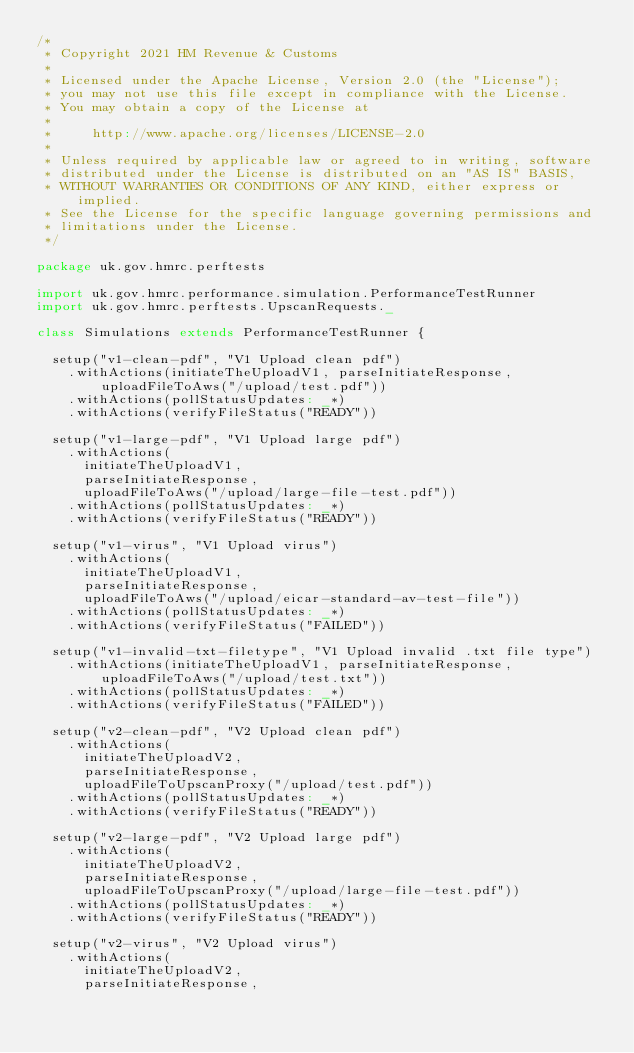<code> <loc_0><loc_0><loc_500><loc_500><_Scala_>/*
 * Copyright 2021 HM Revenue & Customs
 *
 * Licensed under the Apache License, Version 2.0 (the "License");
 * you may not use this file except in compliance with the License.
 * You may obtain a copy of the License at
 *
 *     http://www.apache.org/licenses/LICENSE-2.0
 *
 * Unless required by applicable law or agreed to in writing, software
 * distributed under the License is distributed on an "AS IS" BASIS,
 * WITHOUT WARRANTIES OR CONDITIONS OF ANY KIND, either express or implied.
 * See the License for the specific language governing permissions and
 * limitations under the License.
 */

package uk.gov.hmrc.perftests

import uk.gov.hmrc.performance.simulation.PerformanceTestRunner
import uk.gov.hmrc.perftests.UpscanRequests._

class Simulations extends PerformanceTestRunner {

  setup("v1-clean-pdf", "V1 Upload clean pdf")
    .withActions(initiateTheUploadV1, parseInitiateResponse, uploadFileToAws("/upload/test.pdf"))
    .withActions(pollStatusUpdates: _*)
    .withActions(verifyFileStatus("READY"))

  setup("v1-large-pdf", "V1 Upload large pdf")
    .withActions(
      initiateTheUploadV1,
      parseInitiateResponse,
      uploadFileToAws("/upload/large-file-test.pdf"))
    .withActions(pollStatusUpdates: _*)
    .withActions(verifyFileStatus("READY"))

  setup("v1-virus", "V1 Upload virus")
    .withActions(
      initiateTheUploadV1,
      parseInitiateResponse,
      uploadFileToAws("/upload/eicar-standard-av-test-file"))
    .withActions(pollStatusUpdates: _*)
    .withActions(verifyFileStatus("FAILED"))

  setup("v1-invalid-txt-filetype", "V1 Upload invalid .txt file type")
    .withActions(initiateTheUploadV1, parseInitiateResponse, uploadFileToAws("/upload/test.txt"))
    .withActions(pollStatusUpdates: _*)
    .withActions(verifyFileStatus("FAILED"))

  setup("v2-clean-pdf", "V2 Upload clean pdf")
    .withActions(
      initiateTheUploadV2,
      parseInitiateResponse,
      uploadFileToUpscanProxy("/upload/test.pdf"))
    .withActions(pollStatusUpdates: _*)
    .withActions(verifyFileStatus("READY"))

  setup("v2-large-pdf", "V2 Upload large pdf")
    .withActions(
      initiateTheUploadV2,
      parseInitiateResponse,
      uploadFileToUpscanProxy("/upload/large-file-test.pdf"))
    .withActions(pollStatusUpdates: _*)
    .withActions(verifyFileStatus("READY"))

  setup("v2-virus", "V2 Upload virus")
    .withActions(
      initiateTheUploadV2,
      parseInitiateResponse,</code> 